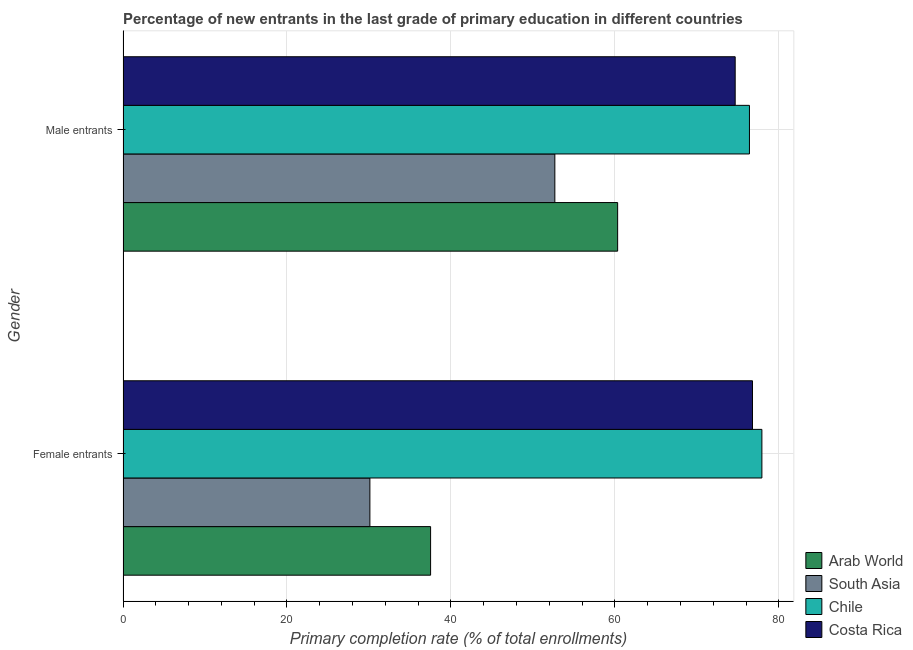How many different coloured bars are there?
Your answer should be compact. 4. How many groups of bars are there?
Your answer should be very brief. 2. How many bars are there on the 1st tick from the top?
Give a very brief answer. 4. What is the label of the 1st group of bars from the top?
Offer a terse response. Male entrants. What is the primary completion rate of male entrants in South Asia?
Offer a very short reply. 52.68. Across all countries, what is the maximum primary completion rate of female entrants?
Provide a succinct answer. 77.93. Across all countries, what is the minimum primary completion rate of male entrants?
Provide a short and direct response. 52.68. In which country was the primary completion rate of female entrants maximum?
Make the answer very short. Chile. In which country was the primary completion rate of male entrants minimum?
Make the answer very short. South Asia. What is the total primary completion rate of male entrants in the graph?
Provide a succinct answer. 264.11. What is the difference between the primary completion rate of female entrants in South Asia and that in Arab World?
Give a very brief answer. -7.41. What is the difference between the primary completion rate of male entrants in Arab World and the primary completion rate of female entrants in Chile?
Give a very brief answer. -17.6. What is the average primary completion rate of female entrants per country?
Offer a terse response. 55.59. What is the difference between the primary completion rate of male entrants and primary completion rate of female entrants in Costa Rica?
Provide a short and direct response. -2.11. What is the ratio of the primary completion rate of male entrants in South Asia to that in Chile?
Your answer should be very brief. 0.69. What does the 3rd bar from the top in Male entrants represents?
Keep it short and to the point. South Asia. What does the 2nd bar from the bottom in Male entrants represents?
Provide a short and direct response. South Asia. How many bars are there?
Your answer should be very brief. 8. Does the graph contain any zero values?
Provide a short and direct response. No. Does the graph contain grids?
Make the answer very short. Yes. What is the title of the graph?
Provide a succinct answer. Percentage of new entrants in the last grade of primary education in different countries. Does "Lower middle income" appear as one of the legend labels in the graph?
Your response must be concise. No. What is the label or title of the X-axis?
Provide a succinct answer. Primary completion rate (% of total enrollments). What is the Primary completion rate (% of total enrollments) in Arab World in Female entrants?
Provide a short and direct response. 37.52. What is the Primary completion rate (% of total enrollments) in South Asia in Female entrants?
Keep it short and to the point. 30.12. What is the Primary completion rate (% of total enrollments) of Chile in Female entrants?
Keep it short and to the point. 77.93. What is the Primary completion rate (% of total enrollments) of Costa Rica in Female entrants?
Give a very brief answer. 76.79. What is the Primary completion rate (% of total enrollments) of Arab World in Male entrants?
Your answer should be very brief. 60.34. What is the Primary completion rate (% of total enrollments) in South Asia in Male entrants?
Provide a succinct answer. 52.68. What is the Primary completion rate (% of total enrollments) in Chile in Male entrants?
Provide a succinct answer. 76.42. What is the Primary completion rate (% of total enrollments) in Costa Rica in Male entrants?
Your answer should be compact. 74.68. Across all Gender, what is the maximum Primary completion rate (% of total enrollments) in Arab World?
Your answer should be compact. 60.34. Across all Gender, what is the maximum Primary completion rate (% of total enrollments) of South Asia?
Make the answer very short. 52.68. Across all Gender, what is the maximum Primary completion rate (% of total enrollments) in Chile?
Your answer should be very brief. 77.93. Across all Gender, what is the maximum Primary completion rate (% of total enrollments) in Costa Rica?
Your response must be concise. 76.79. Across all Gender, what is the minimum Primary completion rate (% of total enrollments) in Arab World?
Give a very brief answer. 37.52. Across all Gender, what is the minimum Primary completion rate (% of total enrollments) in South Asia?
Keep it short and to the point. 30.12. Across all Gender, what is the minimum Primary completion rate (% of total enrollments) in Chile?
Your response must be concise. 76.42. Across all Gender, what is the minimum Primary completion rate (% of total enrollments) of Costa Rica?
Provide a succinct answer. 74.68. What is the total Primary completion rate (% of total enrollments) in Arab World in the graph?
Your answer should be compact. 97.86. What is the total Primary completion rate (% of total enrollments) in South Asia in the graph?
Give a very brief answer. 82.79. What is the total Primary completion rate (% of total enrollments) in Chile in the graph?
Ensure brevity in your answer.  154.35. What is the total Primary completion rate (% of total enrollments) in Costa Rica in the graph?
Offer a terse response. 151.46. What is the difference between the Primary completion rate (% of total enrollments) of Arab World in Female entrants and that in Male entrants?
Ensure brevity in your answer.  -22.82. What is the difference between the Primary completion rate (% of total enrollments) in South Asia in Female entrants and that in Male entrants?
Provide a succinct answer. -22.56. What is the difference between the Primary completion rate (% of total enrollments) of Chile in Female entrants and that in Male entrants?
Your response must be concise. 1.52. What is the difference between the Primary completion rate (% of total enrollments) of Costa Rica in Female entrants and that in Male entrants?
Your answer should be compact. 2.11. What is the difference between the Primary completion rate (% of total enrollments) of Arab World in Female entrants and the Primary completion rate (% of total enrollments) of South Asia in Male entrants?
Your answer should be very brief. -15.16. What is the difference between the Primary completion rate (% of total enrollments) of Arab World in Female entrants and the Primary completion rate (% of total enrollments) of Chile in Male entrants?
Ensure brevity in your answer.  -38.9. What is the difference between the Primary completion rate (% of total enrollments) in Arab World in Female entrants and the Primary completion rate (% of total enrollments) in Costa Rica in Male entrants?
Offer a terse response. -37.16. What is the difference between the Primary completion rate (% of total enrollments) in South Asia in Female entrants and the Primary completion rate (% of total enrollments) in Chile in Male entrants?
Keep it short and to the point. -46.3. What is the difference between the Primary completion rate (% of total enrollments) of South Asia in Female entrants and the Primary completion rate (% of total enrollments) of Costa Rica in Male entrants?
Keep it short and to the point. -44.56. What is the difference between the Primary completion rate (% of total enrollments) of Chile in Female entrants and the Primary completion rate (% of total enrollments) of Costa Rica in Male entrants?
Provide a succinct answer. 3.26. What is the average Primary completion rate (% of total enrollments) in Arab World per Gender?
Keep it short and to the point. 48.93. What is the average Primary completion rate (% of total enrollments) of South Asia per Gender?
Your answer should be very brief. 41.4. What is the average Primary completion rate (% of total enrollments) in Chile per Gender?
Give a very brief answer. 77.18. What is the average Primary completion rate (% of total enrollments) of Costa Rica per Gender?
Offer a very short reply. 75.73. What is the difference between the Primary completion rate (% of total enrollments) of Arab World and Primary completion rate (% of total enrollments) of South Asia in Female entrants?
Offer a terse response. 7.41. What is the difference between the Primary completion rate (% of total enrollments) of Arab World and Primary completion rate (% of total enrollments) of Chile in Female entrants?
Offer a very short reply. -40.41. What is the difference between the Primary completion rate (% of total enrollments) in Arab World and Primary completion rate (% of total enrollments) in Costa Rica in Female entrants?
Your answer should be compact. -39.26. What is the difference between the Primary completion rate (% of total enrollments) of South Asia and Primary completion rate (% of total enrollments) of Chile in Female entrants?
Offer a very short reply. -47.82. What is the difference between the Primary completion rate (% of total enrollments) in South Asia and Primary completion rate (% of total enrollments) in Costa Rica in Female entrants?
Your answer should be very brief. -46.67. What is the difference between the Primary completion rate (% of total enrollments) in Chile and Primary completion rate (% of total enrollments) in Costa Rica in Female entrants?
Offer a very short reply. 1.15. What is the difference between the Primary completion rate (% of total enrollments) in Arab World and Primary completion rate (% of total enrollments) in South Asia in Male entrants?
Your answer should be very brief. 7.66. What is the difference between the Primary completion rate (% of total enrollments) of Arab World and Primary completion rate (% of total enrollments) of Chile in Male entrants?
Make the answer very short. -16.08. What is the difference between the Primary completion rate (% of total enrollments) of Arab World and Primary completion rate (% of total enrollments) of Costa Rica in Male entrants?
Keep it short and to the point. -14.34. What is the difference between the Primary completion rate (% of total enrollments) in South Asia and Primary completion rate (% of total enrollments) in Chile in Male entrants?
Keep it short and to the point. -23.74. What is the difference between the Primary completion rate (% of total enrollments) of South Asia and Primary completion rate (% of total enrollments) of Costa Rica in Male entrants?
Provide a succinct answer. -22. What is the difference between the Primary completion rate (% of total enrollments) in Chile and Primary completion rate (% of total enrollments) in Costa Rica in Male entrants?
Provide a short and direct response. 1.74. What is the ratio of the Primary completion rate (% of total enrollments) in Arab World in Female entrants to that in Male entrants?
Your answer should be compact. 0.62. What is the ratio of the Primary completion rate (% of total enrollments) of South Asia in Female entrants to that in Male entrants?
Provide a succinct answer. 0.57. What is the ratio of the Primary completion rate (% of total enrollments) of Chile in Female entrants to that in Male entrants?
Your answer should be compact. 1.02. What is the ratio of the Primary completion rate (% of total enrollments) of Costa Rica in Female entrants to that in Male entrants?
Your answer should be very brief. 1.03. What is the difference between the highest and the second highest Primary completion rate (% of total enrollments) of Arab World?
Offer a very short reply. 22.82. What is the difference between the highest and the second highest Primary completion rate (% of total enrollments) of South Asia?
Offer a very short reply. 22.56. What is the difference between the highest and the second highest Primary completion rate (% of total enrollments) of Chile?
Provide a succinct answer. 1.52. What is the difference between the highest and the second highest Primary completion rate (% of total enrollments) in Costa Rica?
Ensure brevity in your answer.  2.11. What is the difference between the highest and the lowest Primary completion rate (% of total enrollments) of Arab World?
Your answer should be very brief. 22.82. What is the difference between the highest and the lowest Primary completion rate (% of total enrollments) in South Asia?
Provide a succinct answer. 22.56. What is the difference between the highest and the lowest Primary completion rate (% of total enrollments) in Chile?
Your response must be concise. 1.52. What is the difference between the highest and the lowest Primary completion rate (% of total enrollments) in Costa Rica?
Give a very brief answer. 2.11. 